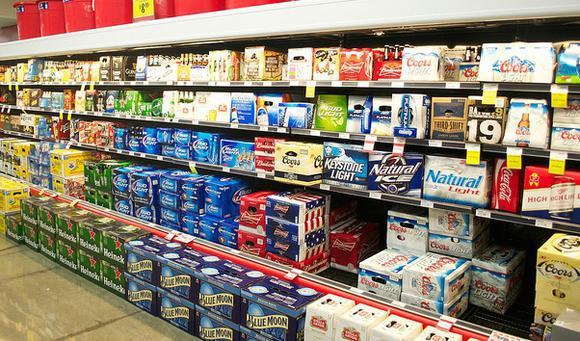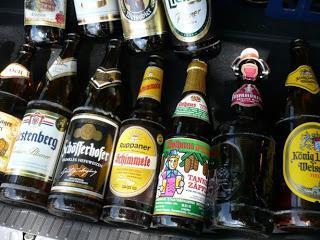The first image is the image on the left, the second image is the image on the right. For the images shown, is this caption "The left and right image contains the same number of glass drinking bottles." true? Answer yes or no. No. The first image is the image on the left, the second image is the image on the right. For the images displayed, is the sentence "There are multiple of the same bottles next to each other." factually correct? Answer yes or no. No. 